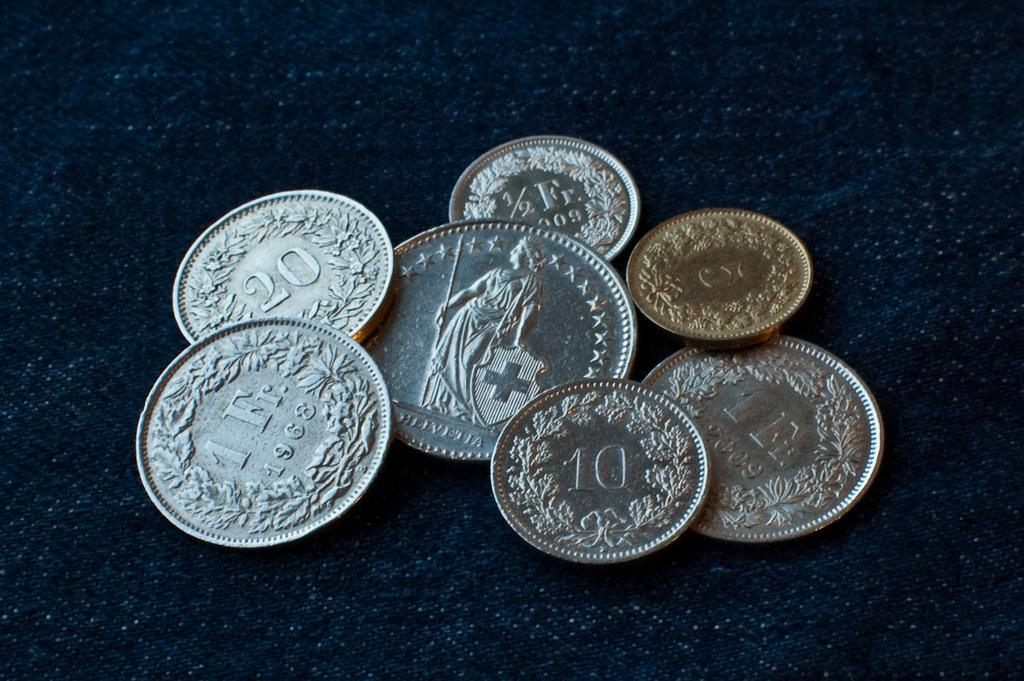<image>
Provide a brief description of the given image. The seven coins are on the blue background, and the one in the middle says Helvetia. 